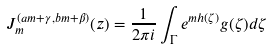Convert formula to latex. <formula><loc_0><loc_0><loc_500><loc_500>J _ { m } ^ { ( a m + \gamma , b m + \beta ) } ( z ) = \frac { 1 } { 2 \pi i } \int _ { \Gamma } e ^ { m h ( \zeta ) } g ( \zeta ) d \zeta</formula> 